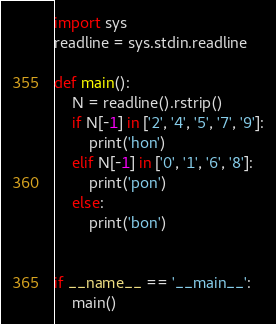<code> <loc_0><loc_0><loc_500><loc_500><_Python_>import sys
readline = sys.stdin.readline

def main():
    N = readline().rstrip()
    if N[-1] in ['2', '4', '5', '7', '9']:
        print('hon')
    elif N[-1] in ['0', '1', '6', '8']:
        print('pon')
    else:
        print('bon')


if __name__ == '__main__':
    main()</code> 